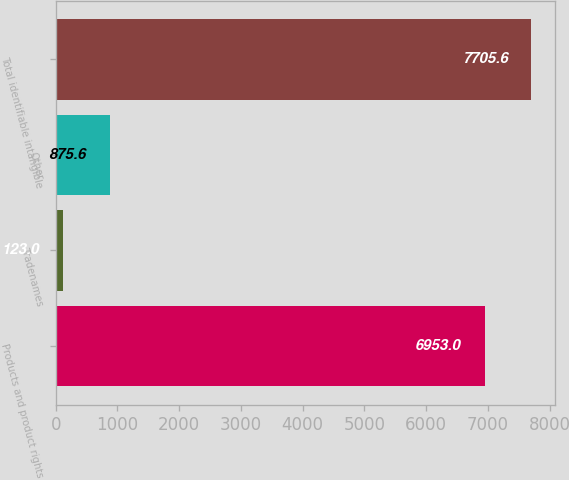Convert chart to OTSL. <chart><loc_0><loc_0><loc_500><loc_500><bar_chart><fcel>Products and product rights<fcel>Tradenames<fcel>Other<fcel>Total identifiable intangible<nl><fcel>6953<fcel>123<fcel>875.6<fcel>7705.6<nl></chart> 